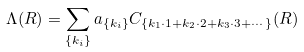Convert formula to latex. <formula><loc_0><loc_0><loc_500><loc_500>\Lambda ( R ) = \sum _ { \{ k _ { i } \} } a _ { \{ k _ { i } \} } C _ { \{ k _ { 1 } \cdot 1 + k _ { 2 } \cdot 2 + k _ { 3 } \cdot 3 + \cdots \} } ( R )</formula> 